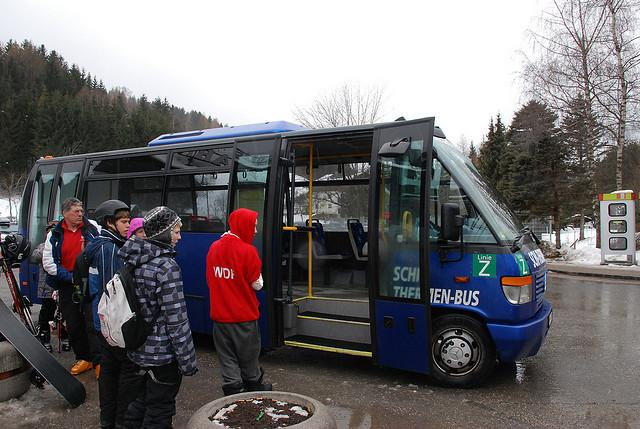Which head covering is made of the hardest material? Please explain your reasoning. black. People are getting into a van and some are wearing hoods while others have helmets on that are plastic rather than made from material. 